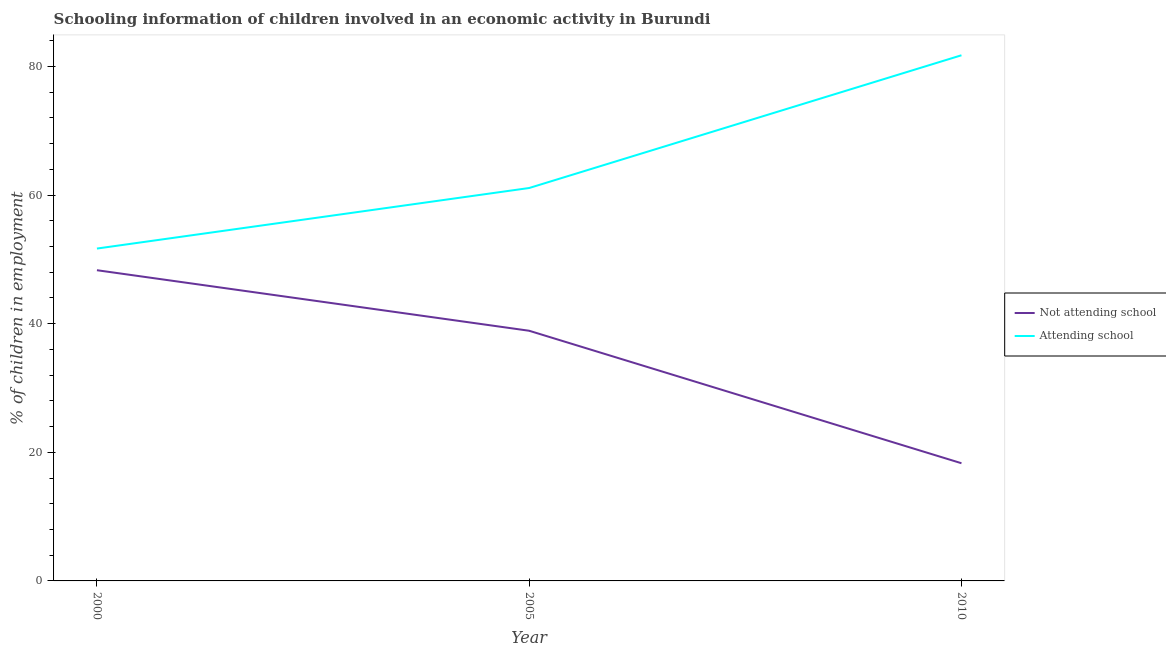How many different coloured lines are there?
Offer a very short reply. 2. Does the line corresponding to percentage of employed children who are attending school intersect with the line corresponding to percentage of employed children who are not attending school?
Your answer should be compact. No. Is the number of lines equal to the number of legend labels?
Make the answer very short. Yes. What is the percentage of employed children who are not attending school in 2000?
Your answer should be compact. 48.32. Across all years, what is the maximum percentage of employed children who are not attending school?
Provide a succinct answer. 48.32. In which year was the percentage of employed children who are attending school maximum?
Provide a short and direct response. 2010. In which year was the percentage of employed children who are not attending school minimum?
Your response must be concise. 2010. What is the total percentage of employed children who are attending school in the graph?
Offer a very short reply. 194.52. What is the difference between the percentage of employed children who are attending school in 2000 and that in 2010?
Ensure brevity in your answer.  -30.05. What is the difference between the percentage of employed children who are attending school in 2010 and the percentage of employed children who are not attending school in 2000?
Your response must be concise. 33.42. What is the average percentage of employed children who are not attending school per year?
Offer a terse response. 35.17. In the year 2000, what is the difference between the percentage of employed children who are not attending school and percentage of employed children who are attending school?
Give a very brief answer. -3.37. What is the ratio of the percentage of employed children who are attending school in 2000 to that in 2005?
Provide a short and direct response. 0.85. Is the difference between the percentage of employed children who are not attending school in 2000 and 2010 greater than the difference between the percentage of employed children who are attending school in 2000 and 2010?
Make the answer very short. Yes. What is the difference between the highest and the second highest percentage of employed children who are attending school?
Your answer should be compact. 20.64. What is the difference between the highest and the lowest percentage of employed children who are not attending school?
Offer a very short reply. 30.02. In how many years, is the percentage of employed children who are not attending school greater than the average percentage of employed children who are not attending school taken over all years?
Keep it short and to the point. 2. Is the sum of the percentage of employed children who are attending school in 2005 and 2010 greater than the maximum percentage of employed children who are not attending school across all years?
Your answer should be compact. Yes. Is the percentage of employed children who are attending school strictly less than the percentage of employed children who are not attending school over the years?
Offer a very short reply. No. How many lines are there?
Keep it short and to the point. 2. What is the difference between two consecutive major ticks on the Y-axis?
Your answer should be very brief. 20. Are the values on the major ticks of Y-axis written in scientific E-notation?
Your answer should be compact. No. Does the graph contain any zero values?
Provide a short and direct response. No. Does the graph contain grids?
Make the answer very short. No. How are the legend labels stacked?
Offer a very short reply. Vertical. What is the title of the graph?
Ensure brevity in your answer.  Schooling information of children involved in an economic activity in Burundi. What is the label or title of the Y-axis?
Your answer should be very brief. % of children in employment. What is the % of children in employment of Not attending school in 2000?
Provide a short and direct response. 48.32. What is the % of children in employment in Attending school in 2000?
Your answer should be very brief. 51.68. What is the % of children in employment of Not attending school in 2005?
Your answer should be very brief. 38.9. What is the % of children in employment in Attending school in 2005?
Provide a short and direct response. 61.1. What is the % of children in employment of Attending school in 2010?
Offer a terse response. 81.74. Across all years, what is the maximum % of children in employment of Not attending school?
Your answer should be compact. 48.32. Across all years, what is the maximum % of children in employment of Attending school?
Give a very brief answer. 81.74. Across all years, what is the minimum % of children in employment of Not attending school?
Provide a short and direct response. 18.3. Across all years, what is the minimum % of children in employment in Attending school?
Your answer should be very brief. 51.68. What is the total % of children in employment in Not attending school in the graph?
Your response must be concise. 105.52. What is the total % of children in employment in Attending school in the graph?
Your answer should be compact. 194.52. What is the difference between the % of children in employment in Not attending school in 2000 and that in 2005?
Make the answer very short. 9.42. What is the difference between the % of children in employment in Attending school in 2000 and that in 2005?
Ensure brevity in your answer.  -9.42. What is the difference between the % of children in employment in Not attending school in 2000 and that in 2010?
Ensure brevity in your answer.  30.02. What is the difference between the % of children in employment of Attending school in 2000 and that in 2010?
Ensure brevity in your answer.  -30.05. What is the difference between the % of children in employment in Not attending school in 2005 and that in 2010?
Give a very brief answer. 20.6. What is the difference between the % of children in employment of Attending school in 2005 and that in 2010?
Provide a short and direct response. -20.64. What is the difference between the % of children in employment in Not attending school in 2000 and the % of children in employment in Attending school in 2005?
Make the answer very short. -12.78. What is the difference between the % of children in employment in Not attending school in 2000 and the % of children in employment in Attending school in 2010?
Offer a terse response. -33.42. What is the difference between the % of children in employment in Not attending school in 2005 and the % of children in employment in Attending school in 2010?
Your answer should be compact. -42.84. What is the average % of children in employment in Not attending school per year?
Give a very brief answer. 35.17. What is the average % of children in employment in Attending school per year?
Your response must be concise. 64.84. In the year 2000, what is the difference between the % of children in employment of Not attending school and % of children in employment of Attending school?
Ensure brevity in your answer.  -3.37. In the year 2005, what is the difference between the % of children in employment of Not attending school and % of children in employment of Attending school?
Ensure brevity in your answer.  -22.2. In the year 2010, what is the difference between the % of children in employment in Not attending school and % of children in employment in Attending school?
Give a very brief answer. -63.44. What is the ratio of the % of children in employment of Not attending school in 2000 to that in 2005?
Your answer should be compact. 1.24. What is the ratio of the % of children in employment of Attending school in 2000 to that in 2005?
Provide a succinct answer. 0.85. What is the ratio of the % of children in employment of Not attending school in 2000 to that in 2010?
Your answer should be compact. 2.64. What is the ratio of the % of children in employment of Attending school in 2000 to that in 2010?
Make the answer very short. 0.63. What is the ratio of the % of children in employment in Not attending school in 2005 to that in 2010?
Offer a very short reply. 2.13. What is the ratio of the % of children in employment in Attending school in 2005 to that in 2010?
Offer a terse response. 0.75. What is the difference between the highest and the second highest % of children in employment in Not attending school?
Offer a very short reply. 9.42. What is the difference between the highest and the second highest % of children in employment of Attending school?
Your response must be concise. 20.64. What is the difference between the highest and the lowest % of children in employment of Not attending school?
Offer a terse response. 30.02. What is the difference between the highest and the lowest % of children in employment in Attending school?
Provide a short and direct response. 30.05. 